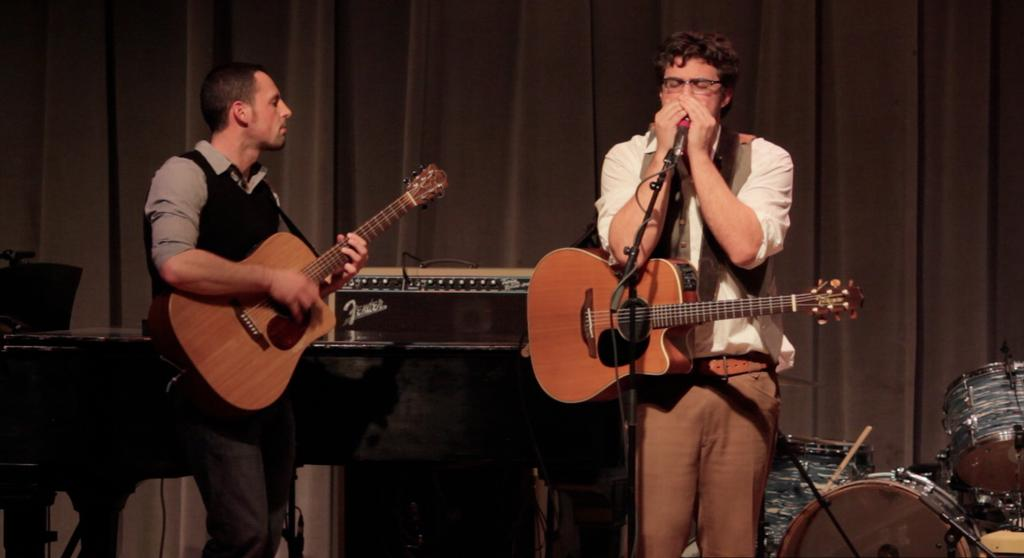How many people are in the image? There are two men in the image. What are the men doing in the image? The men are standing and holding guitars. Is one of the men holding anything else besides a guitar? Yes, one of the men is holding a microphone. What can be seen in the background of the image? There is a drum set in the background of the image. Where is the daughter of the man holding the microphone in the image? There is no daughter present in the image. What type of tray is being used by the men in the image? There is no tray visible in the image. 